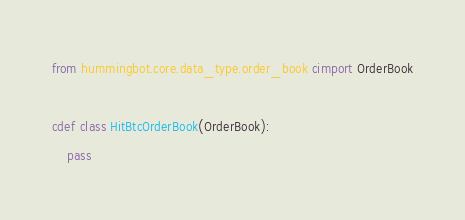Convert code to text. <code><loc_0><loc_0><loc_500><loc_500><_Cython_>from hummingbot.core.data_type.order_book cimport OrderBook

cdef class HitBtcOrderBook(OrderBook):
    pass</code> 